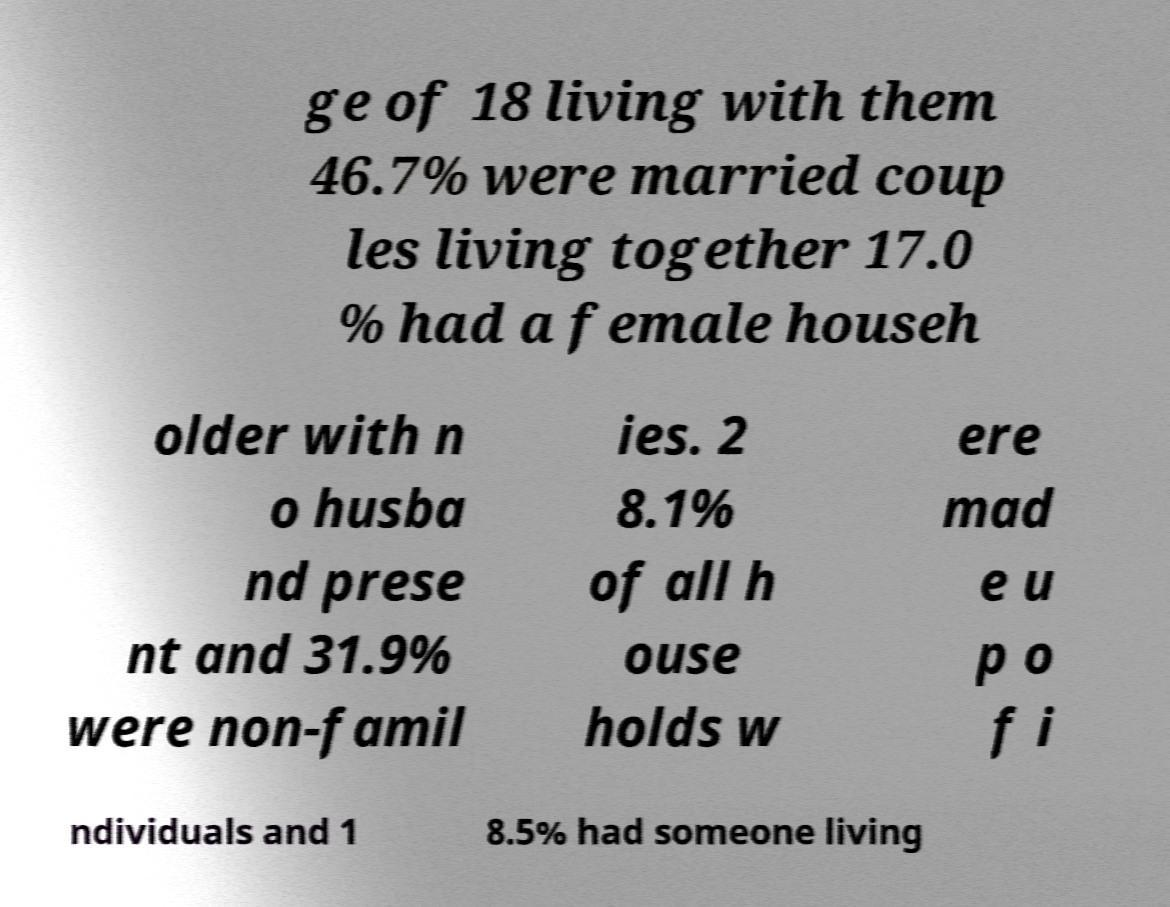Could you assist in decoding the text presented in this image and type it out clearly? ge of 18 living with them 46.7% were married coup les living together 17.0 % had a female househ older with n o husba nd prese nt and 31.9% were non-famil ies. 2 8.1% of all h ouse holds w ere mad e u p o f i ndividuals and 1 8.5% had someone living 